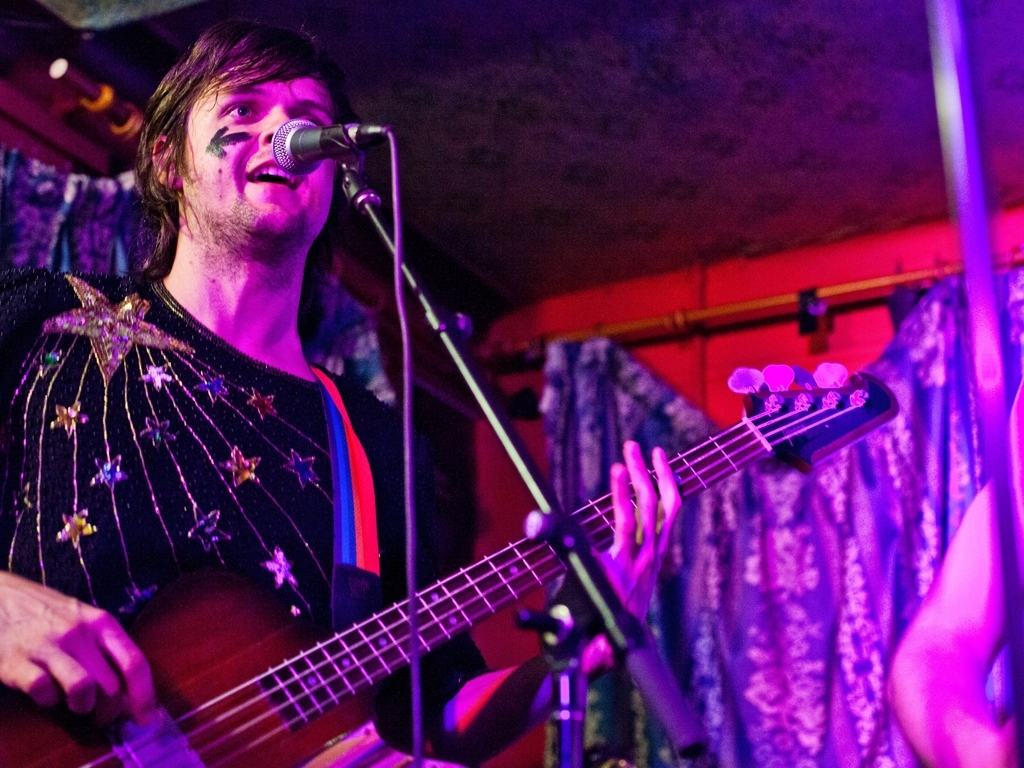What can you infer about the musician’s style from his choice of clothing? The musician’s choice of clothing, featuring a glittery, star-patterned top, suggests a style that is bold and creative. This fashion choice may reflect a flamboyant or theatrical element in his performance, hinting at a genre of music that embraces individuality and showmanship. 